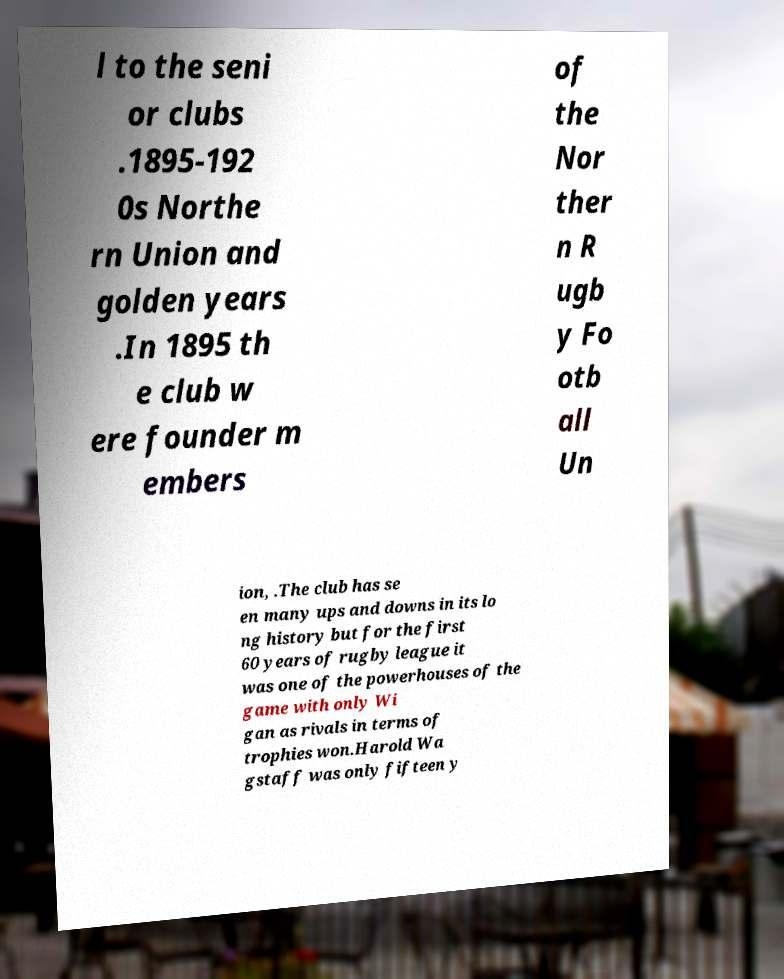I need the written content from this picture converted into text. Can you do that? l to the seni or clubs .1895-192 0s Northe rn Union and golden years .In 1895 th e club w ere founder m embers of the Nor ther n R ugb y Fo otb all Un ion, .The club has se en many ups and downs in its lo ng history but for the first 60 years of rugby league it was one of the powerhouses of the game with only Wi gan as rivals in terms of trophies won.Harold Wa gstaff was only fifteen y 